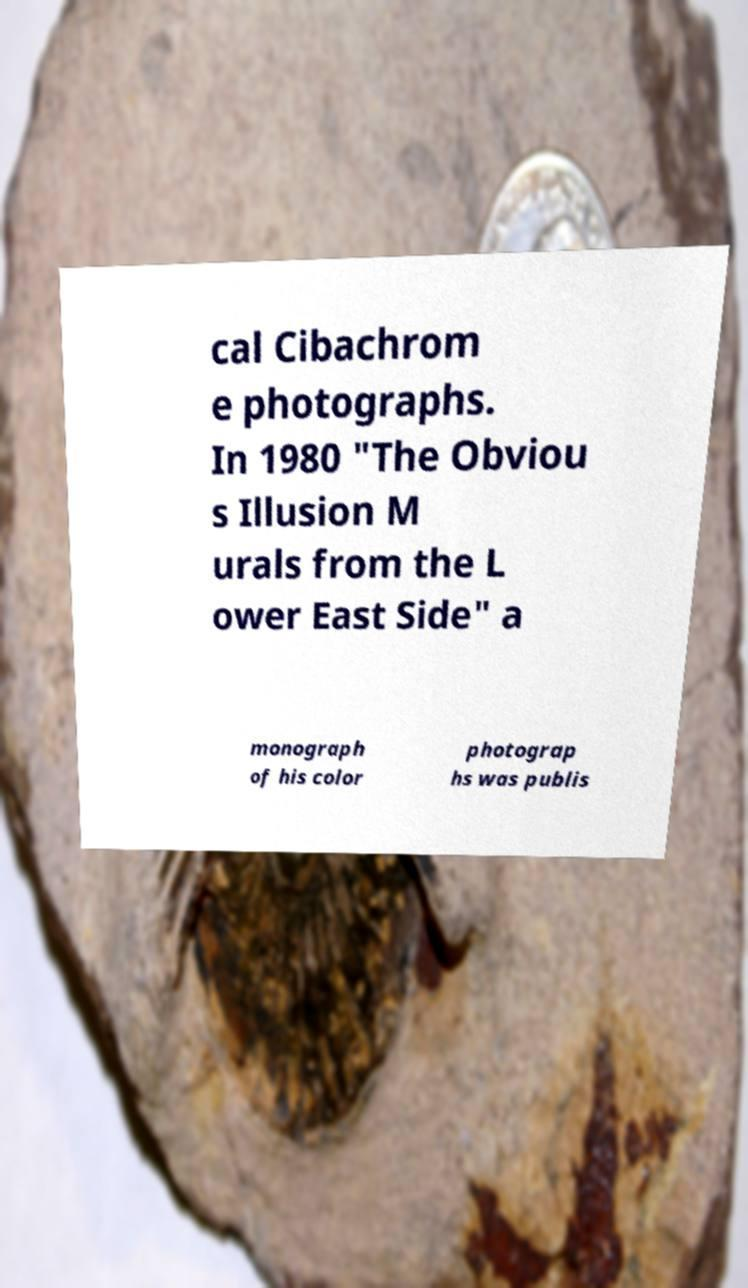Please read and relay the text visible in this image. What does it say? cal Cibachrom e photographs. In 1980 "The Obviou s Illusion M urals from the L ower East Side" a monograph of his color photograp hs was publis 